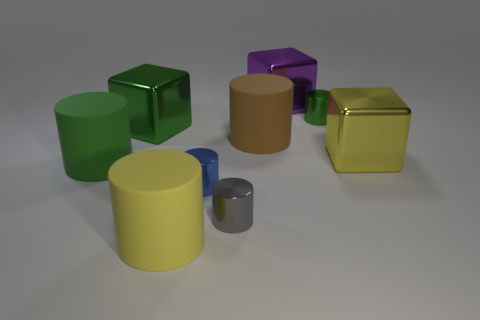Subtract 2 cylinders. How many cylinders are left? 4 Subtract all tiny blue metallic cylinders. How many cylinders are left? 5 Subtract all brown cylinders. How many cylinders are left? 5 Add 1 big green cubes. How many objects exist? 10 Subtract all green cylinders. Subtract all green spheres. How many cylinders are left? 4 Subtract all blocks. How many objects are left? 6 Subtract 1 yellow cylinders. How many objects are left? 8 Subtract all big purple metal blocks. Subtract all tiny blue blocks. How many objects are left? 8 Add 7 small blue cylinders. How many small blue cylinders are left? 8 Add 5 tiny cyan matte cylinders. How many tiny cyan matte cylinders exist? 5 